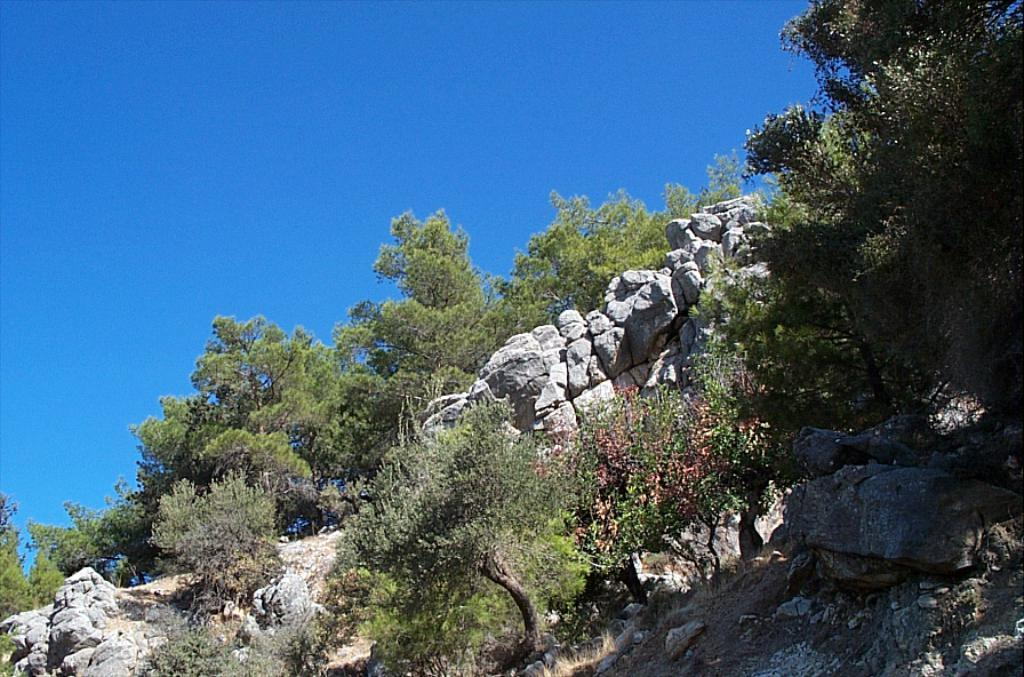What type of natural vegetation is present in the image? There are trees in the image. What type of geological formation can be seen in the image? There are rocks in the image. What part of the natural environment is visible in the background of the image? The sky is visible in the background of the image. What type of art can be seen hanging on the trees in the image? There is no art present in the image; it features trees and rocks. What type of rock is being used for reading in the image? There is no rock being used for reading in the image; rocks are geological formations and not associated with reading. 